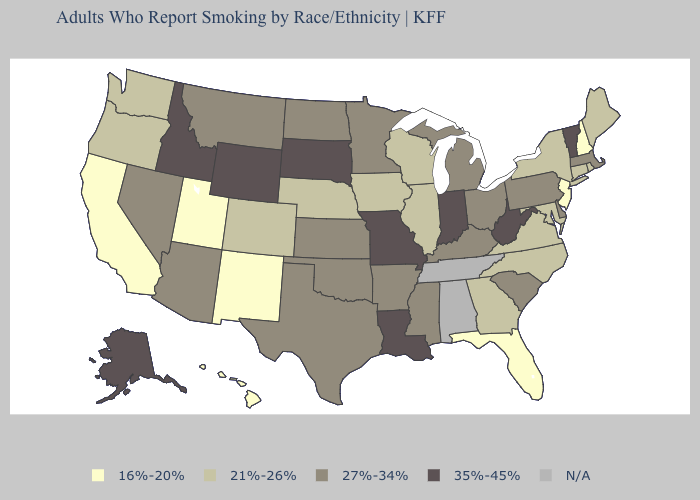Does Rhode Island have the highest value in the Northeast?
Keep it brief. No. Which states have the highest value in the USA?
Concise answer only. Alaska, Idaho, Indiana, Louisiana, Missouri, South Dakota, Vermont, West Virginia, Wyoming. Among the states that border Louisiana , which have the highest value?
Keep it brief. Arkansas, Mississippi, Texas. What is the highest value in the USA?
Short answer required. 35%-45%. What is the value of Mississippi?
Answer briefly. 27%-34%. What is the value of South Carolina?
Concise answer only. 27%-34%. What is the value of Arizona?
Write a very short answer. 27%-34%. Does the first symbol in the legend represent the smallest category?
Be succinct. Yes. Which states have the highest value in the USA?
Give a very brief answer. Alaska, Idaho, Indiana, Louisiana, Missouri, South Dakota, Vermont, West Virginia, Wyoming. Among the states that border Kentucky , does Indiana have the lowest value?
Write a very short answer. No. Does Mississippi have the lowest value in the South?
Be succinct. No. Name the states that have a value in the range 21%-26%?
Be succinct. Colorado, Connecticut, Georgia, Illinois, Iowa, Maine, Maryland, Nebraska, New York, North Carolina, Oregon, Rhode Island, Virginia, Washington, Wisconsin. Name the states that have a value in the range 21%-26%?
Short answer required. Colorado, Connecticut, Georgia, Illinois, Iowa, Maine, Maryland, Nebraska, New York, North Carolina, Oregon, Rhode Island, Virginia, Washington, Wisconsin. What is the value of Hawaii?
Quick response, please. 16%-20%. What is the highest value in states that border Minnesota?
Give a very brief answer. 35%-45%. 